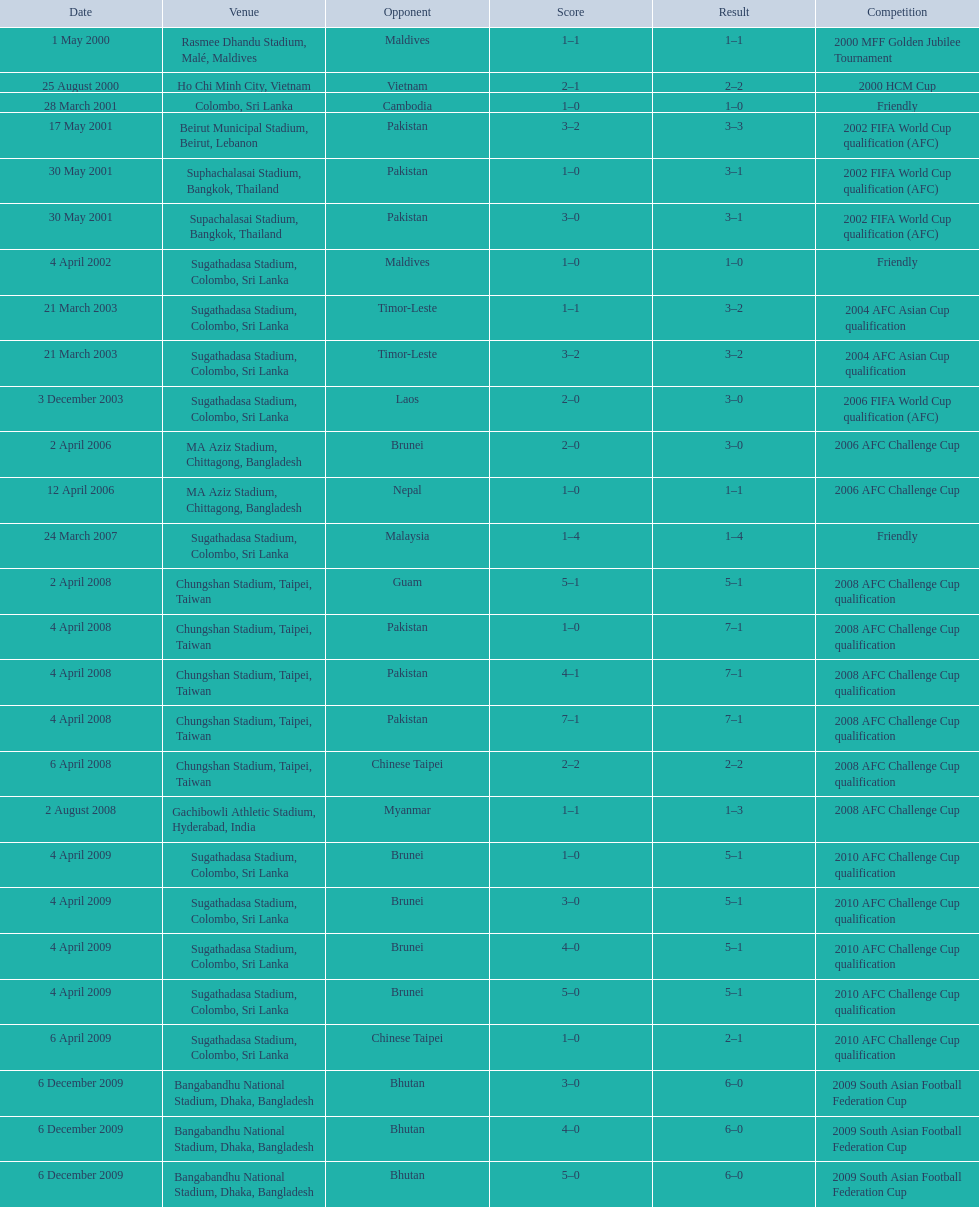How many instances was laos the opposition? 1. 